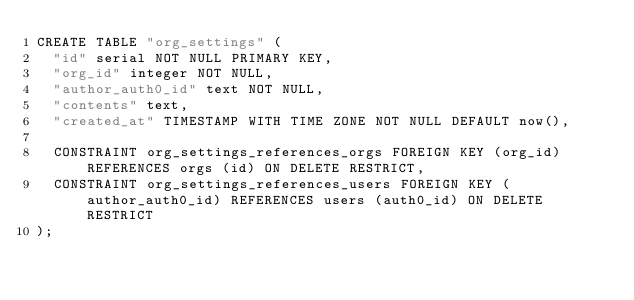Convert code to text. <code><loc_0><loc_0><loc_500><loc_500><_SQL_>CREATE TABLE "org_settings" (
	"id" serial NOT NULL PRIMARY KEY,
	"org_id" integer NOT NULL,
	"author_auth0_id" text NOT NULL, 
	"contents" text,
	"created_at" TIMESTAMP WITH TIME ZONE NOT NULL DEFAULT now(),

	CONSTRAINT org_settings_references_orgs FOREIGN KEY (org_id) REFERENCES orgs (id) ON DELETE RESTRICT,
	CONSTRAINT org_settings_references_users FOREIGN KEY (author_auth0_id) REFERENCES users (auth0_id) ON DELETE RESTRICT
);</code> 